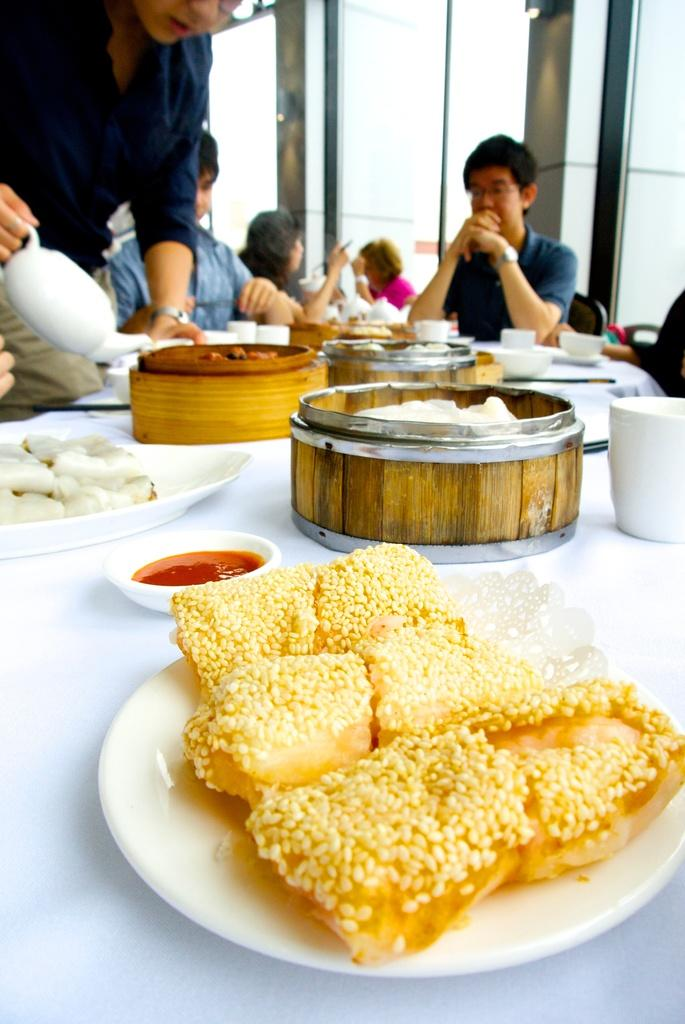What type of containers are holding the eatables in the image? The eatables are in boxes and on plates. What is the man doing with the kettle in the image? The man is filling a cup with a kettle. Are there any other people present in the image? Yes, there are people around the table. What type of plane is flying over the table in the image? There is no plane visible in the image; it only shows people around a table with eatables. 